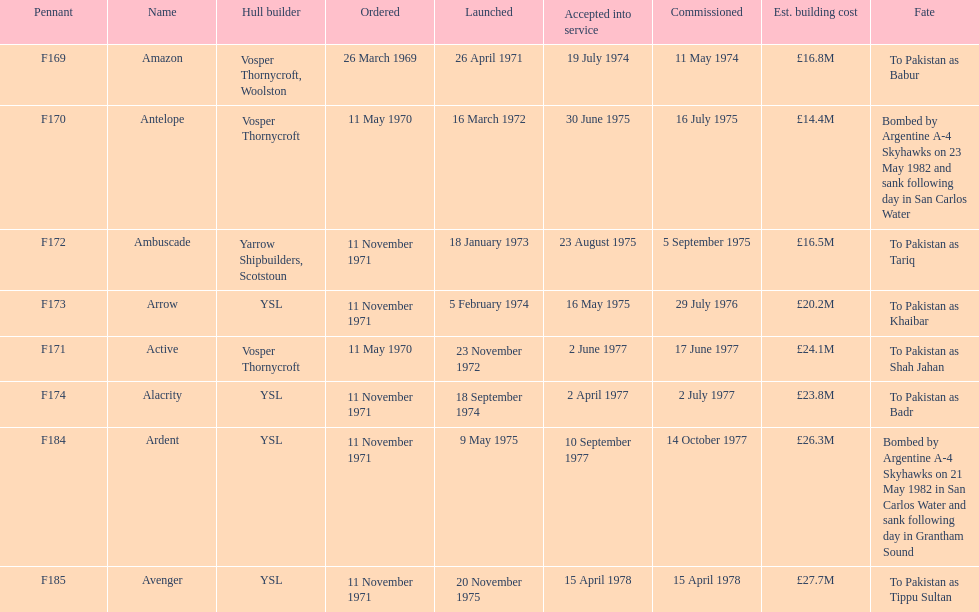Which vessel had the greatest estimated construction cost? Avenger. 